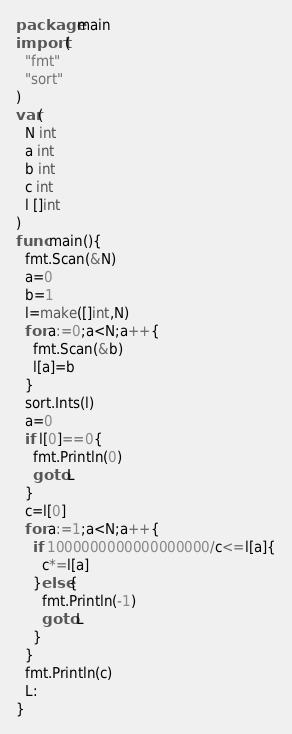<code> <loc_0><loc_0><loc_500><loc_500><_Go_>package main
import (
  "fmt"
  "sort"
)
var(
  N int
  a int
  b int
  c int
  l []int
)
func main(){
  fmt.Scan(&N)
  a=0
  b=1
  l=make([]int,N)
  for a:=0;a<N;a++{
    fmt.Scan(&b)
    l[a]=b
  }
  sort.Ints(l)
  a=0
  if l[0]==0{
    fmt.Println(0)
    goto L
  }
  c=l[0]
  for a:=1;a<N;a++{
    if 1000000000000000000/c<=l[a]{
      c*=l[a]
    }else{
      fmt.Println(-1)
      goto L
    }
  }
  fmt.Println(c)
  L:
}</code> 